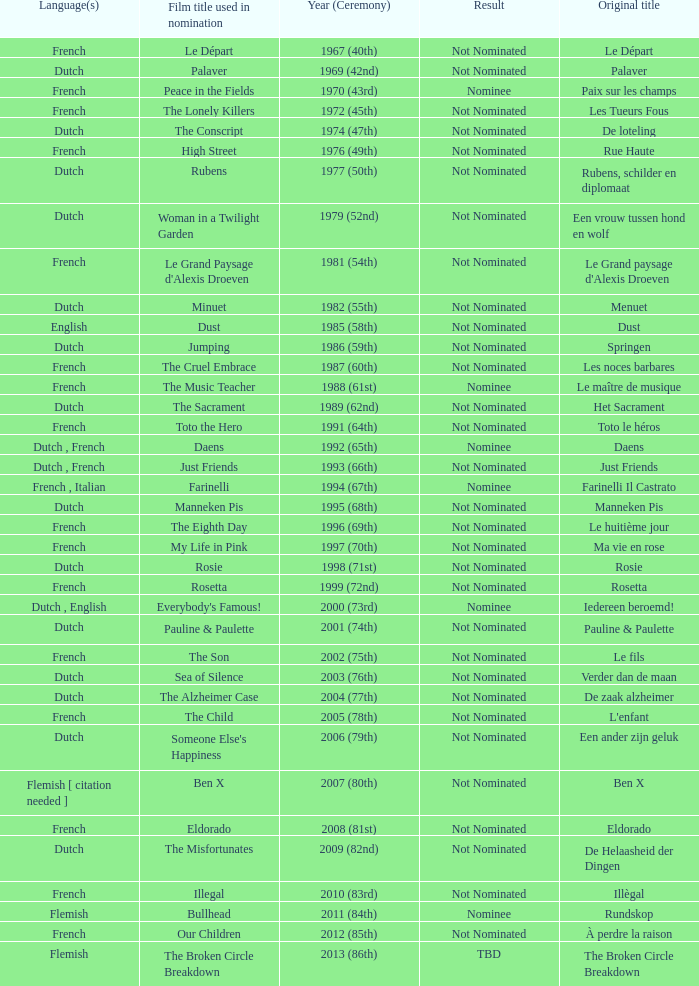What was the title used for Rosie, the film nominated for the dutch language? Rosie. 